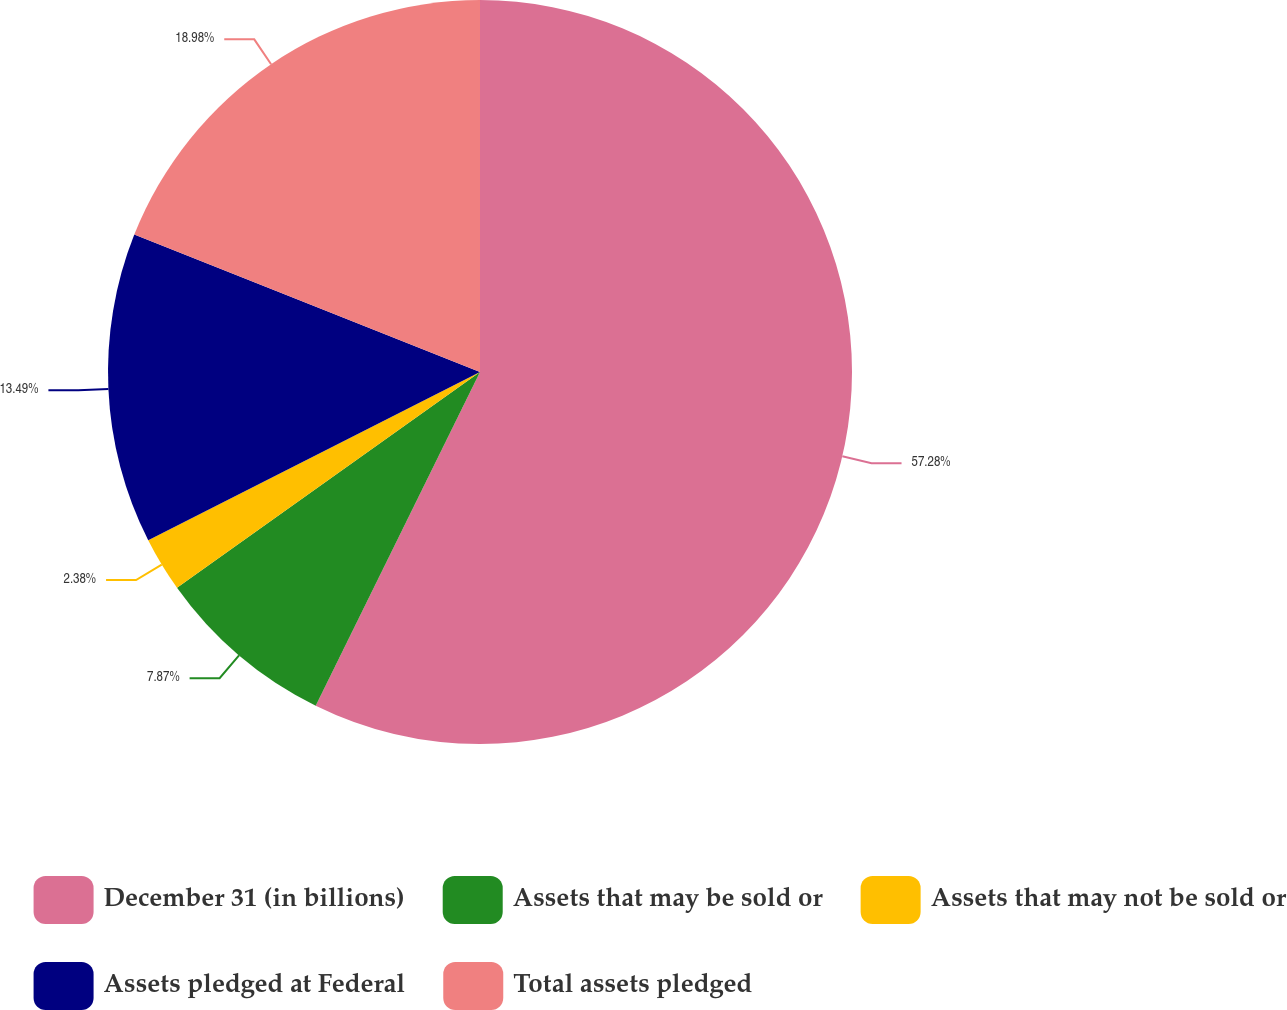<chart> <loc_0><loc_0><loc_500><loc_500><pie_chart><fcel>December 31 (in billions)<fcel>Assets that may be sold or<fcel>Assets that may not be sold or<fcel>Assets pledged at Federal<fcel>Total assets pledged<nl><fcel>57.28%<fcel>7.87%<fcel>2.38%<fcel>13.49%<fcel>18.98%<nl></chart> 